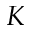<formula> <loc_0><loc_0><loc_500><loc_500>K</formula> 